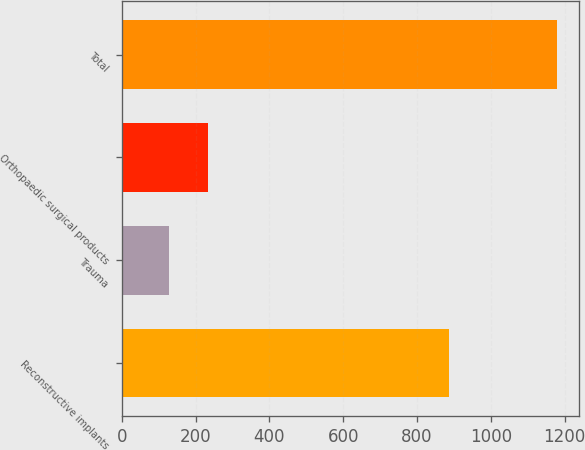Convert chart. <chart><loc_0><loc_0><loc_500><loc_500><bar_chart><fcel>Reconstructive implants<fcel>Trauma<fcel>Orthopaedic surgical products<fcel>Total<nl><fcel>886.5<fcel>128.3<fcel>233.33<fcel>1178.6<nl></chart> 